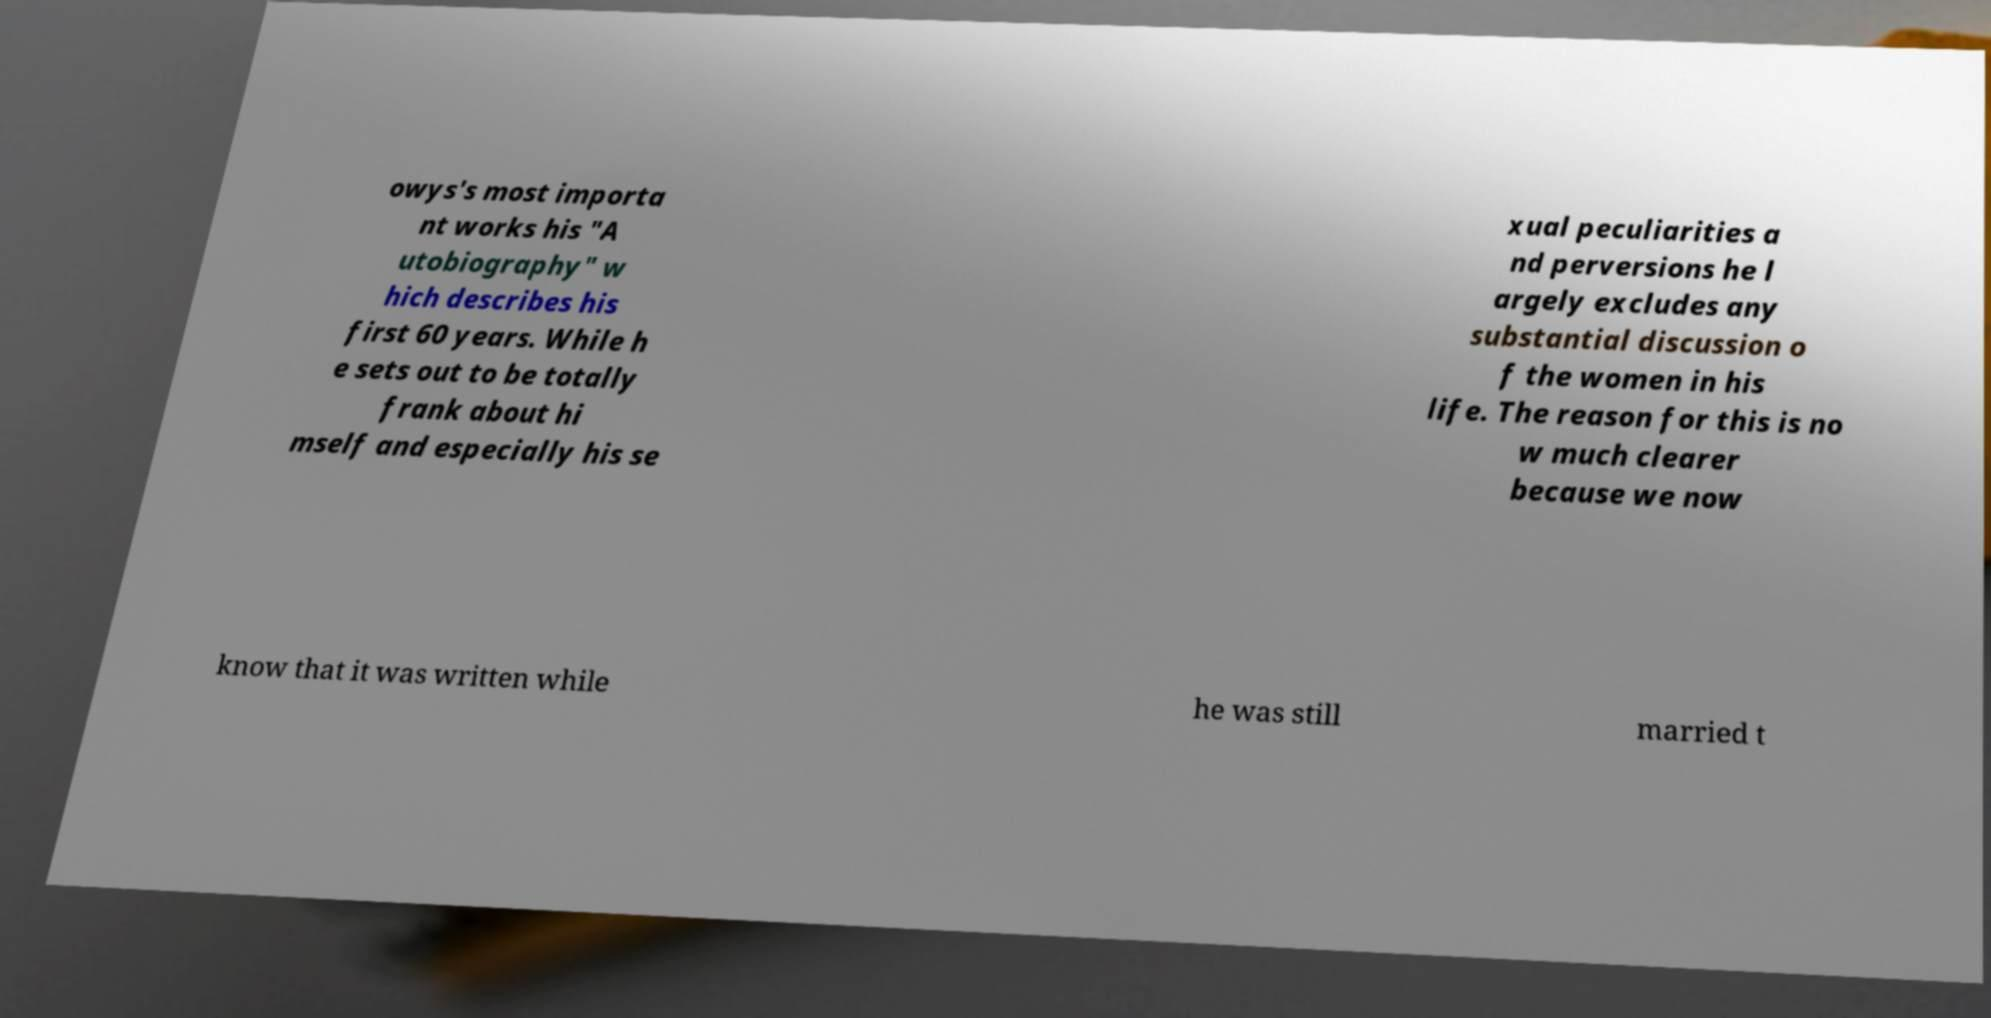Could you assist in decoding the text presented in this image and type it out clearly? owys's most importa nt works his "A utobiography" w hich describes his first 60 years. While h e sets out to be totally frank about hi mself and especially his se xual peculiarities a nd perversions he l argely excludes any substantial discussion o f the women in his life. The reason for this is no w much clearer because we now know that it was written while he was still married t 